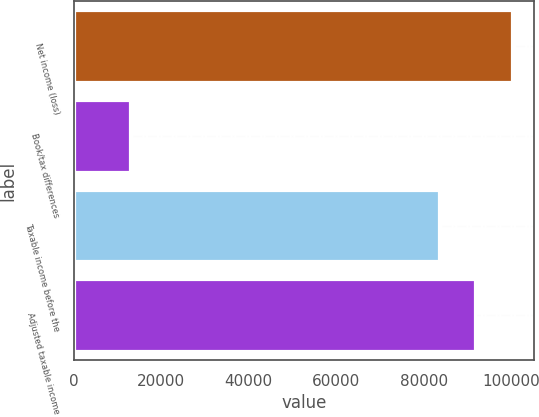Convert chart. <chart><loc_0><loc_0><loc_500><loc_500><bar_chart><fcel>Net income (loss)<fcel>Book/tax differences<fcel>Taxable income before the<fcel>Adjusted taxable income<nl><fcel>100109<fcel>12885<fcel>83424<fcel>91766.4<nl></chart> 